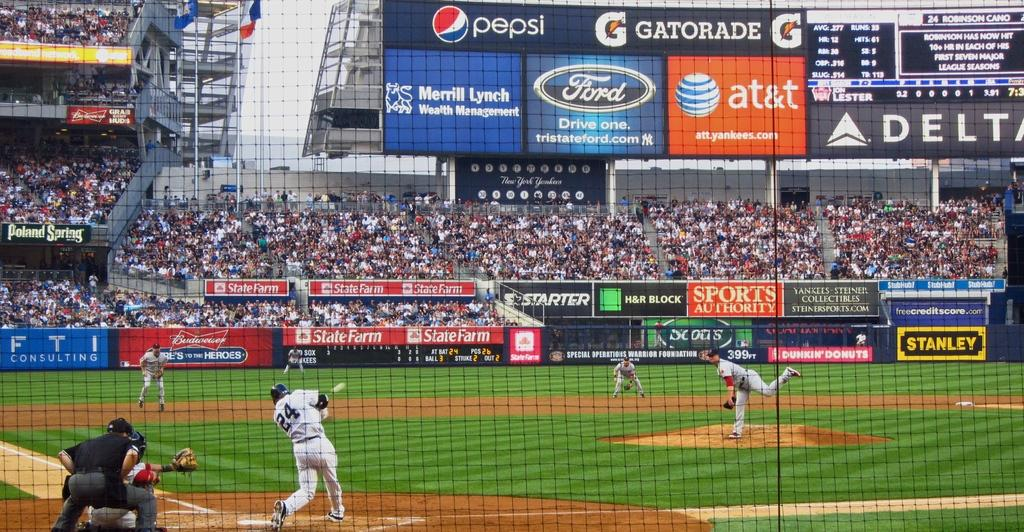Provide a one-sentence caption for the provided image. Batter number 24 swings to hit a ball thrown by the pitcher. 